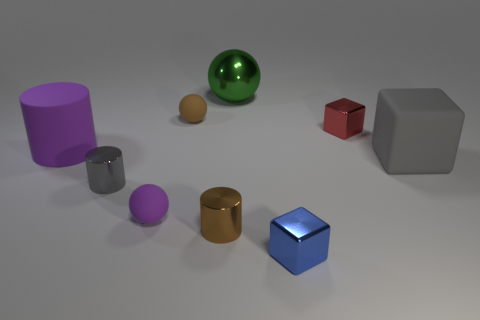How many small shiny cylinders have the same color as the large block?
Offer a very short reply. 1. There is a object that is the same color as the rubber cylinder; what is its material?
Make the answer very short. Rubber. There is a blue shiny object; are there any large matte objects to the left of it?
Give a very brief answer. Yes. The gray object that is on the left side of the purple thing that is in front of the gray rubber cube is made of what material?
Offer a terse response. Metal. There is a gray rubber thing that is the same shape as the red object; what is its size?
Keep it short and to the point. Large. Do the big metal thing and the rubber cube have the same color?
Your response must be concise. No. What color is the tiny thing that is to the left of the big green object and behind the small gray metallic thing?
Your answer should be very brief. Brown. Do the cube that is in front of the gray rubber object and the large gray thing have the same size?
Offer a terse response. No. Is there anything else that has the same shape as the blue object?
Your answer should be very brief. Yes. Is the tiny gray object made of the same material as the tiny brown thing behind the purple sphere?
Offer a very short reply. No. 